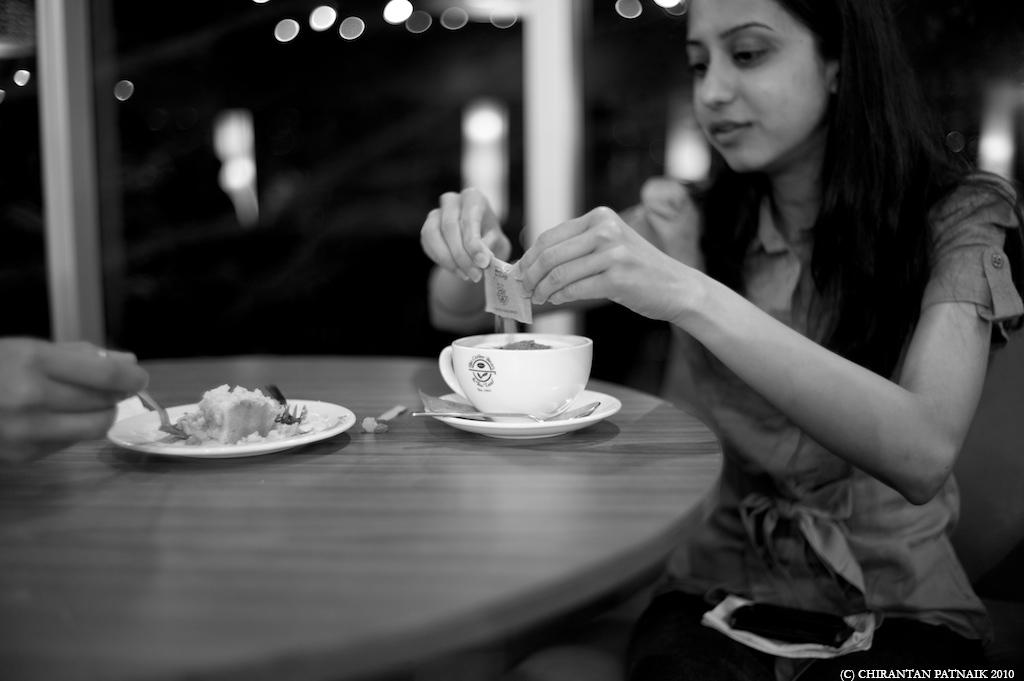What is the woman doing in the image? The woman is sitting in the image. What object is on the table in the image? There is a cup on the table in the image. Whose hand is visible in the image? There is a hand of another person visible in the image. What is on the plate on the table in the image? There is a plate with food on the table in the image. What type of flesh can be seen in the image? There is no flesh visible in the image. What is the plot of the story being told in the image? The image does not depict a story or plot; it is a static scene. 